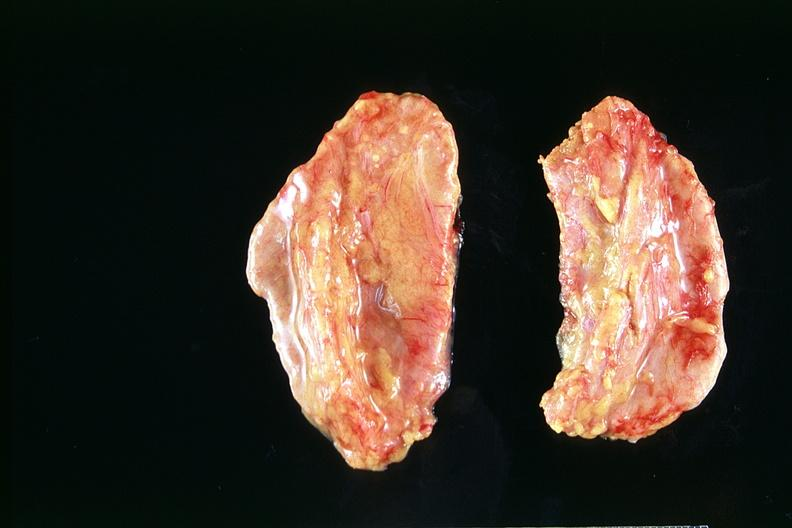does this image show adrenals, normal?
Answer the question using a single word or phrase. Yes 